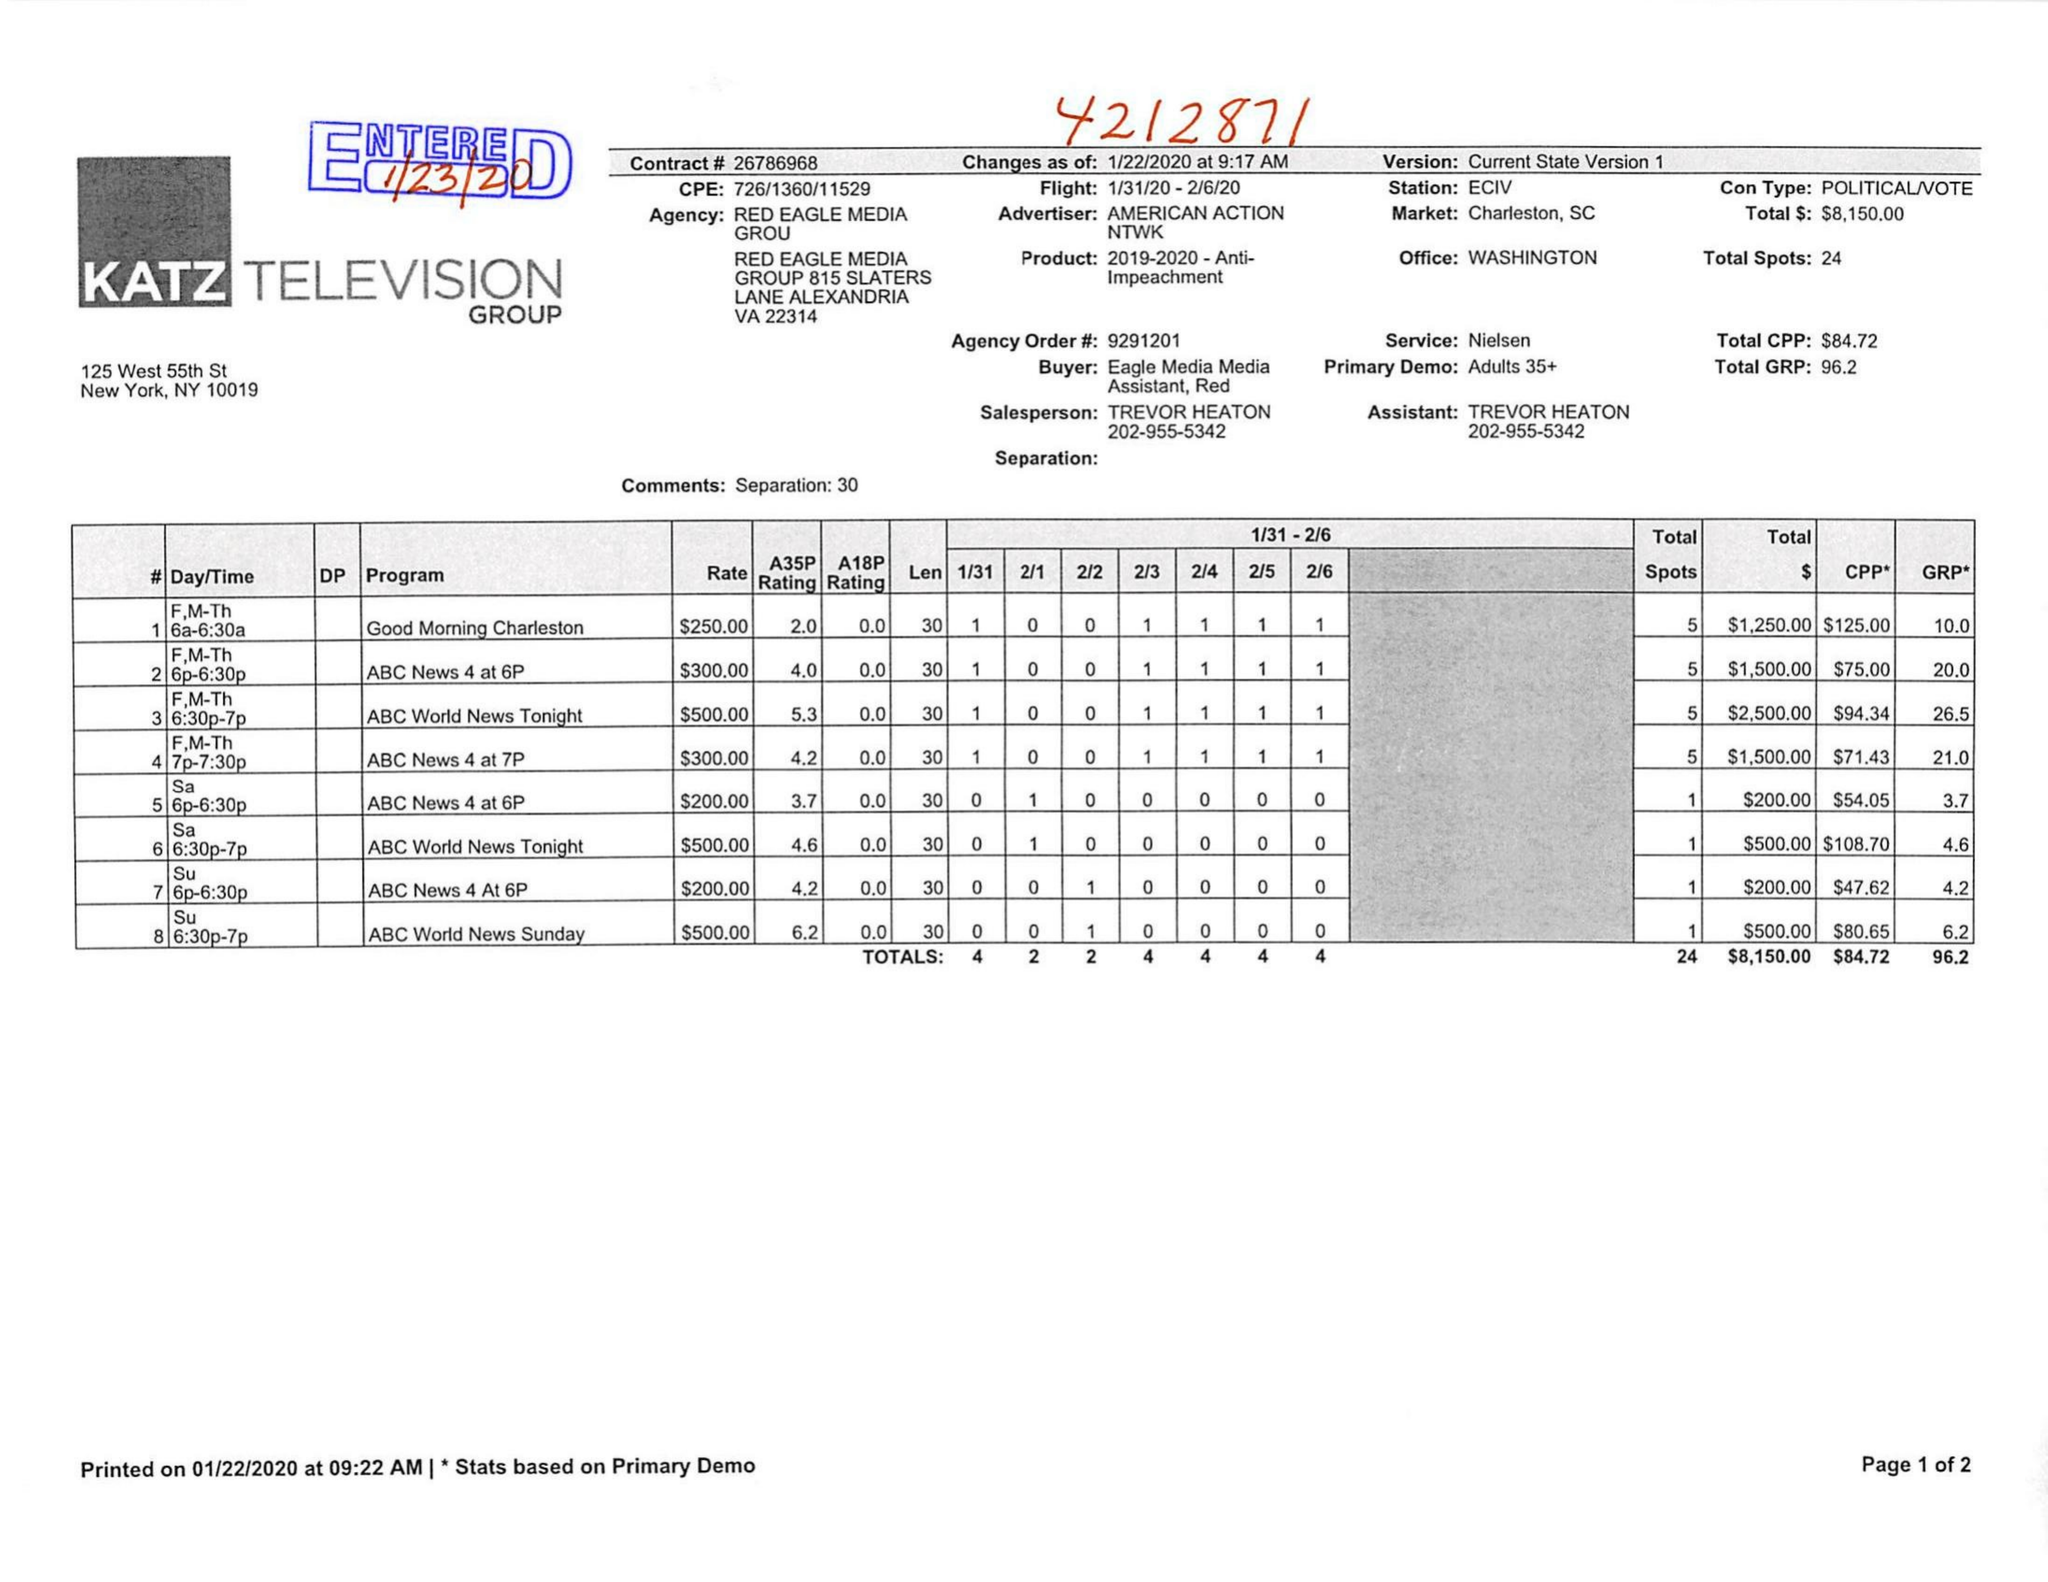What is the value for the flight_from?
Answer the question using a single word or phrase. 01/31/20 